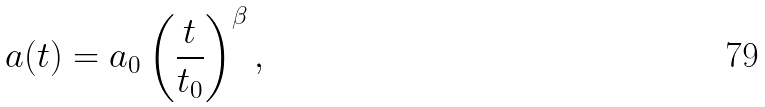<formula> <loc_0><loc_0><loc_500><loc_500>a ( t ) = a _ { 0 } \left ( \frac { t } { t _ { 0 } } \right ) ^ { \beta } ,</formula> 